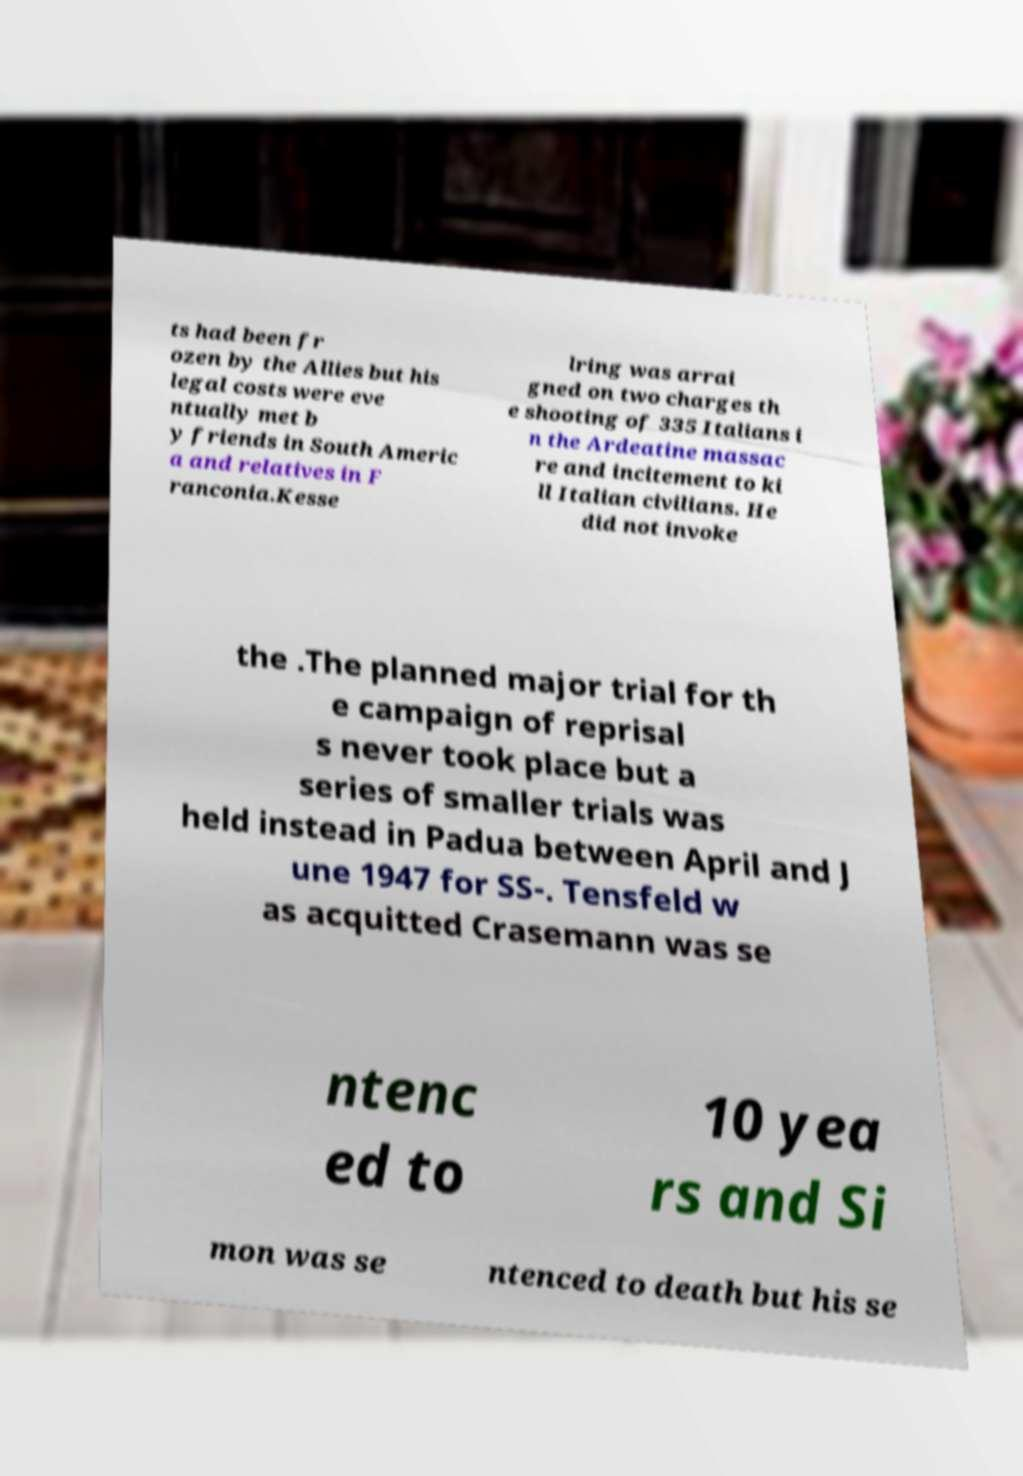Please read and relay the text visible in this image. What does it say? ts had been fr ozen by the Allies but his legal costs were eve ntually met b y friends in South Americ a and relatives in F ranconia.Kesse lring was arrai gned on two charges th e shooting of 335 Italians i n the Ardeatine massac re and incitement to ki ll Italian civilians. He did not invoke the .The planned major trial for th e campaign of reprisal s never took place but a series of smaller trials was held instead in Padua between April and J une 1947 for SS-. Tensfeld w as acquitted Crasemann was se ntenc ed to 10 yea rs and Si mon was se ntenced to death but his se 